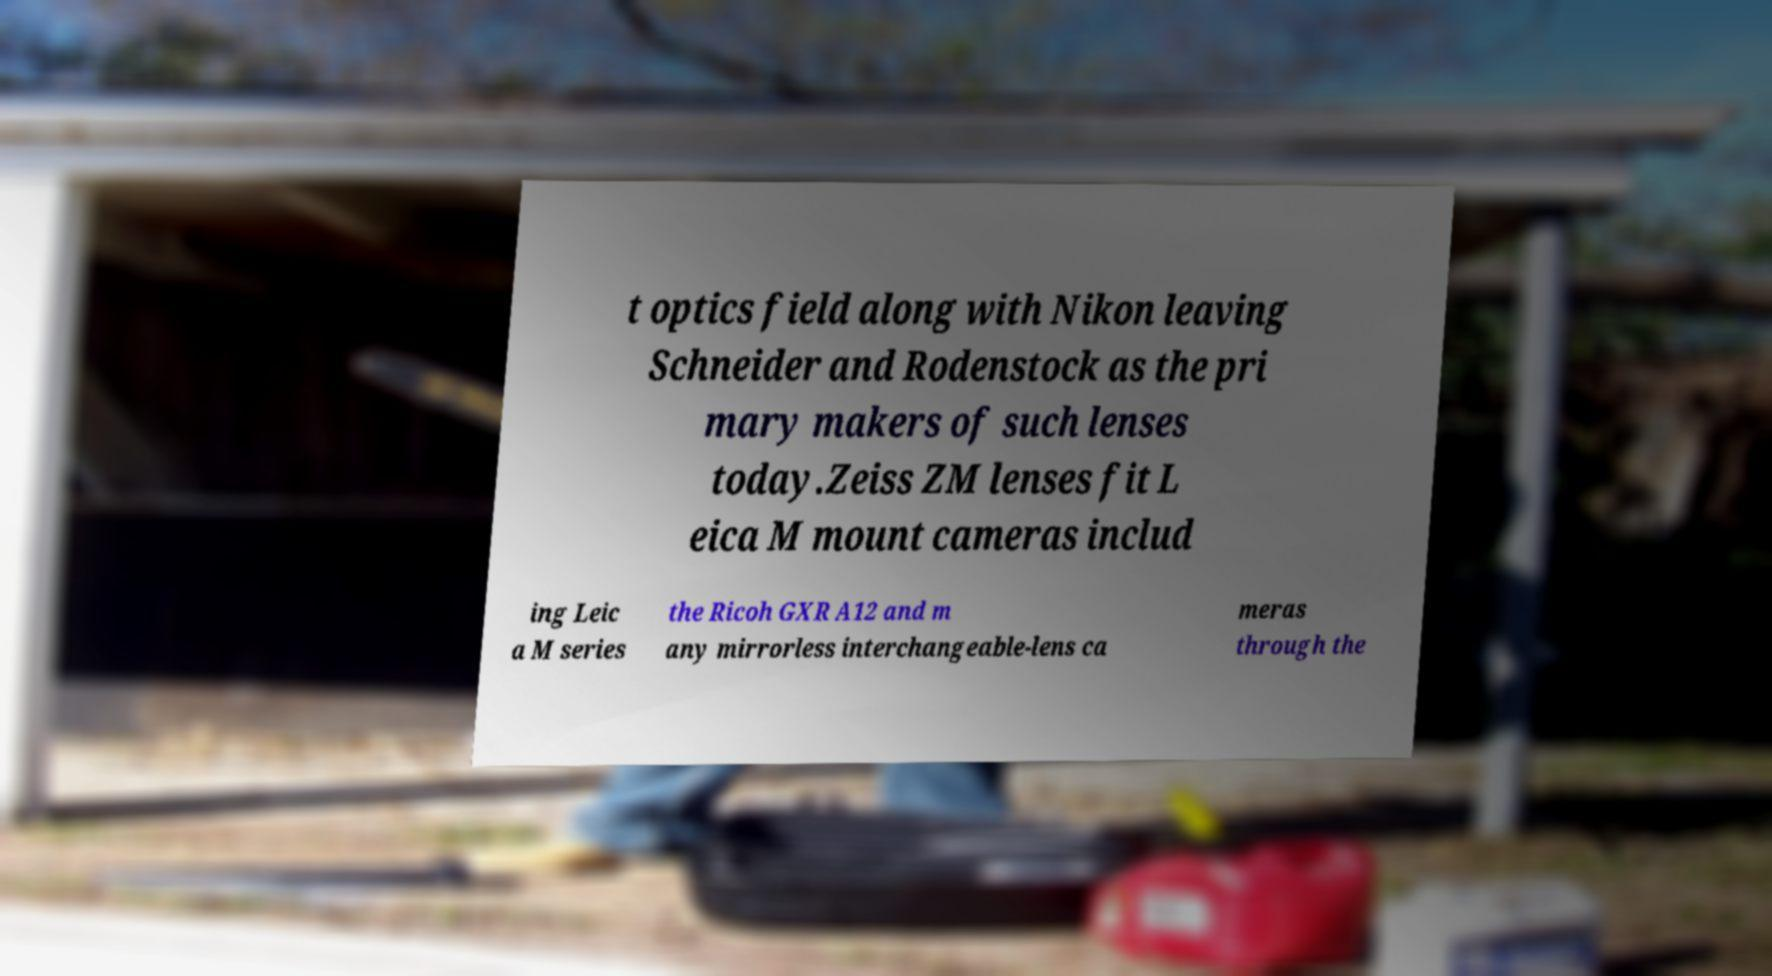What messages or text are displayed in this image? I need them in a readable, typed format. t optics field along with Nikon leaving Schneider and Rodenstock as the pri mary makers of such lenses today.Zeiss ZM lenses fit L eica M mount cameras includ ing Leic a M series the Ricoh GXR A12 and m any mirrorless interchangeable-lens ca meras through the 